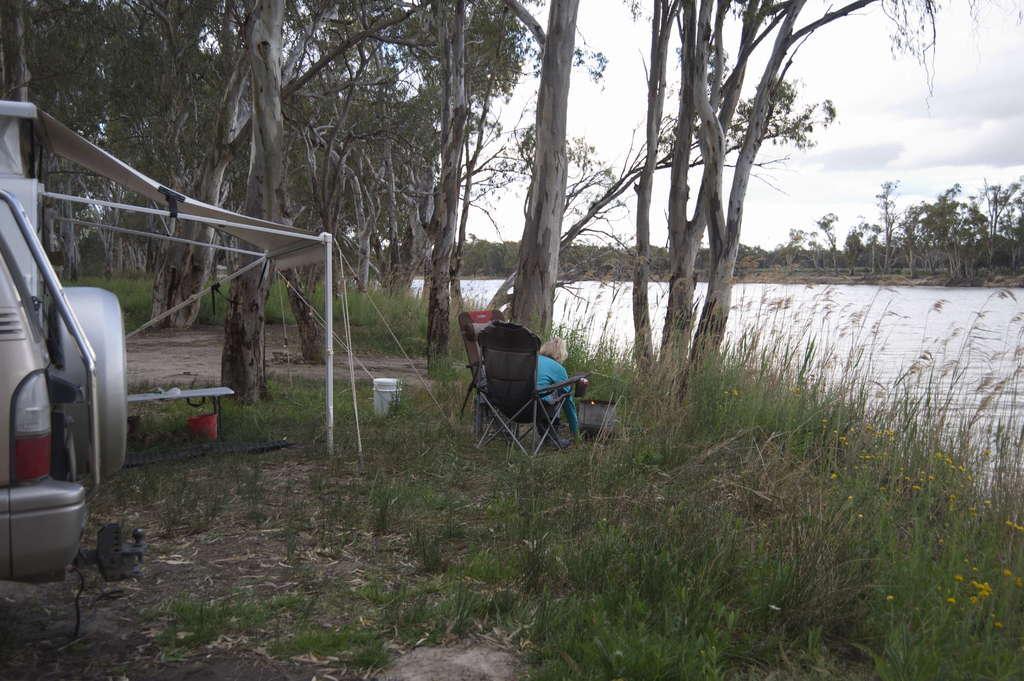In one or two sentences, can you explain what this image depicts? As we can see in the image there is a vehicle, grass, a woman sitting on chair, trees, water and sky. 